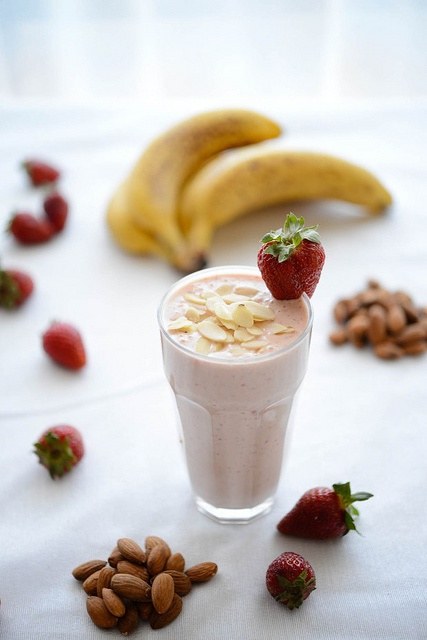Describe the objects in this image and their specific colors. I can see cup in lightblue, darkgray, lightgray, and tan tones, banana in lightblue, orange, tan, olive, and ivory tones, banana in lightblue, tan, and olive tones, and banana in lightblue, orange, tan, and khaki tones in this image. 